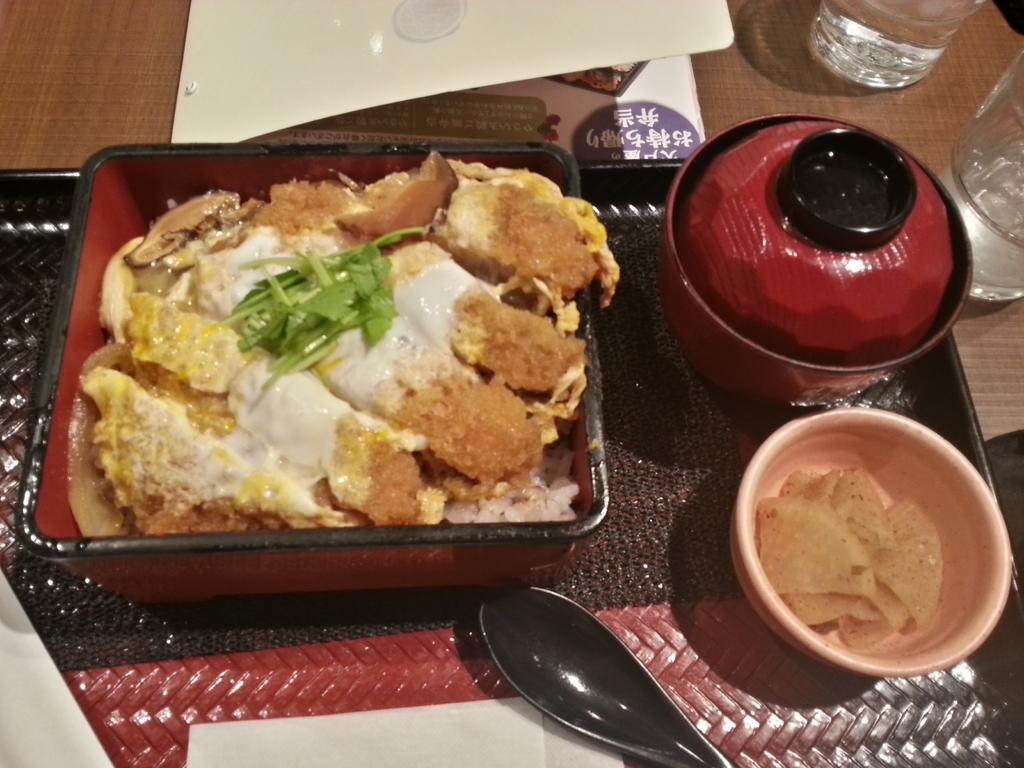Can you describe this image briefly? Here in this picture we can see a table, on which we can see a tray with a couple of bowls and a box, which is full of food items and we can also see a spoon and beside that we can see glasses of water present. 